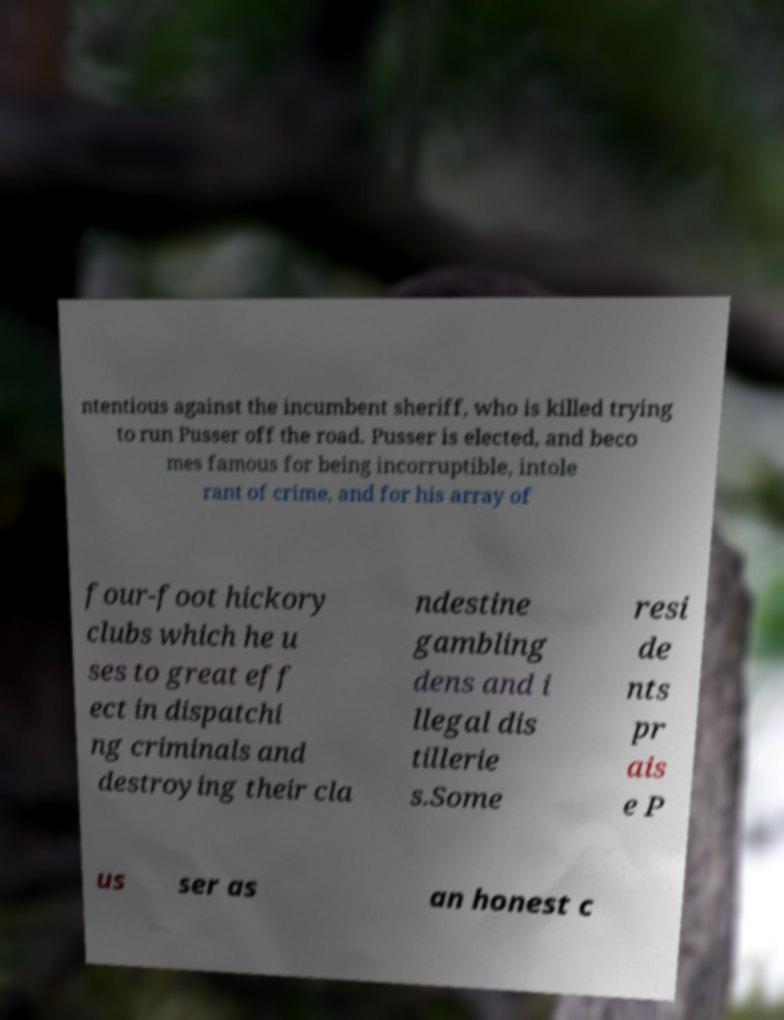There's text embedded in this image that I need extracted. Can you transcribe it verbatim? ntentious against the incumbent sheriff, who is killed trying to run Pusser off the road. Pusser is elected, and beco mes famous for being incorruptible, intole rant of crime, and for his array of four-foot hickory clubs which he u ses to great eff ect in dispatchi ng criminals and destroying their cla ndestine gambling dens and i llegal dis tillerie s.Some resi de nts pr ais e P us ser as an honest c 